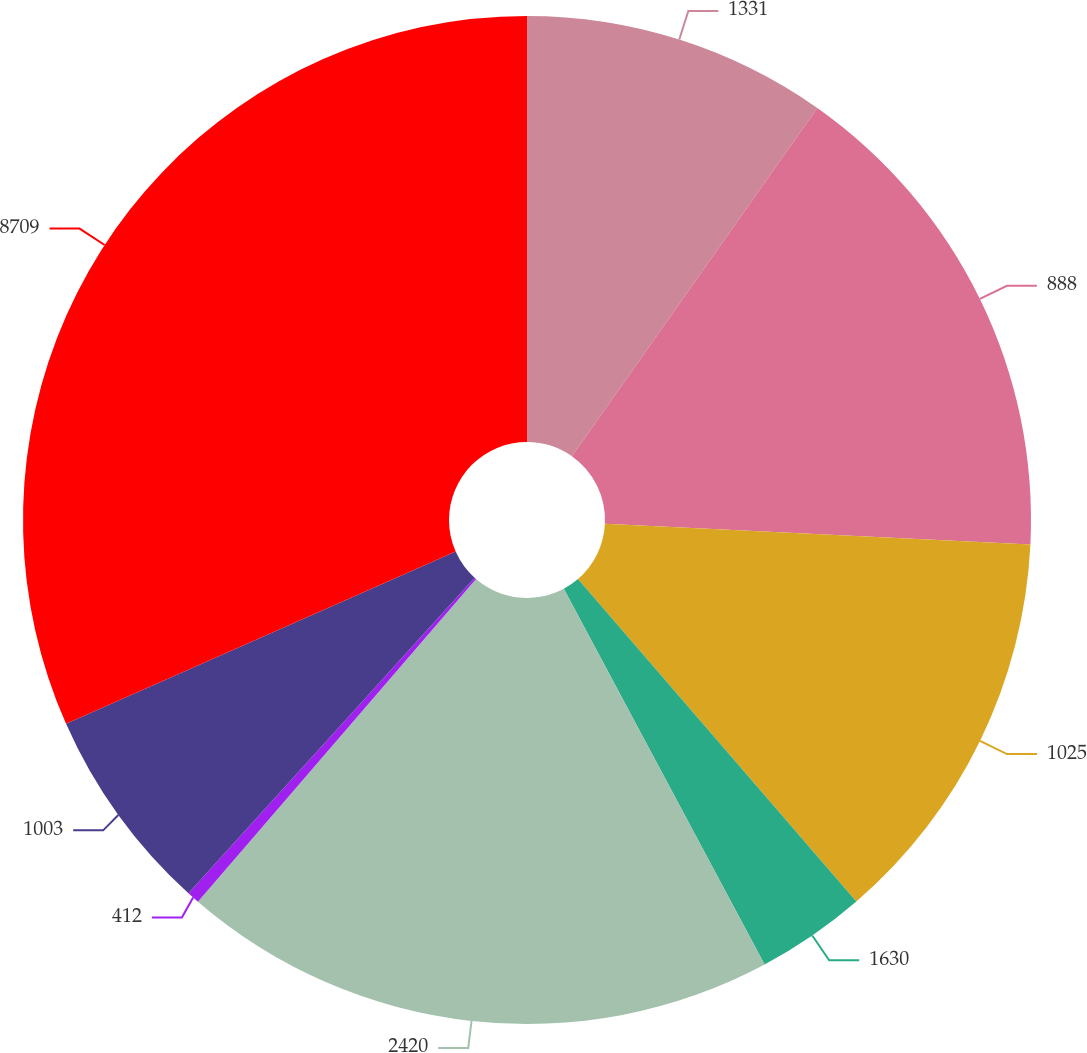Convert chart. <chart><loc_0><loc_0><loc_500><loc_500><pie_chart><fcel>1331<fcel>888<fcel>1025<fcel>1630<fcel>2420<fcel>412<fcel>1003<fcel>8709<nl><fcel>9.77%<fcel>16.01%<fcel>12.89%<fcel>3.52%<fcel>19.14%<fcel>0.4%<fcel>6.65%<fcel>31.63%<nl></chart> 